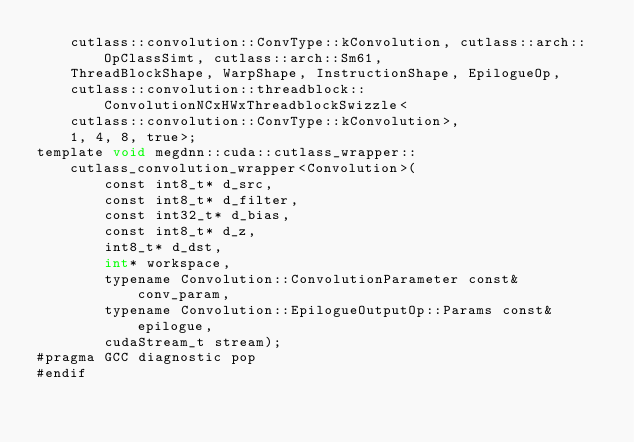<code> <loc_0><loc_0><loc_500><loc_500><_Cuda_>    cutlass::convolution::ConvType::kConvolution, cutlass::arch::OpClassSimt, cutlass::arch::Sm61, 
    ThreadBlockShape, WarpShape, InstructionShape, EpilogueOp, 
    cutlass::convolution::threadblock::ConvolutionNCxHWxThreadblockSwizzle<
    cutlass::convolution::ConvType::kConvolution>, 
    1, 4, 8, true>;
template void megdnn::cuda::cutlass_wrapper::cutlass_convolution_wrapper<Convolution>(
        const int8_t* d_src, 
        const int8_t* d_filter, 
        const int32_t* d_bias, 
        const int8_t* d_z, 
        int8_t* d_dst, 
        int* workspace, 
        typename Convolution::ConvolutionParameter const& conv_param, 
        typename Convolution::EpilogueOutputOp::Params const& epilogue, 
        cudaStream_t stream);
#pragma GCC diagnostic pop
#endif
</code> 